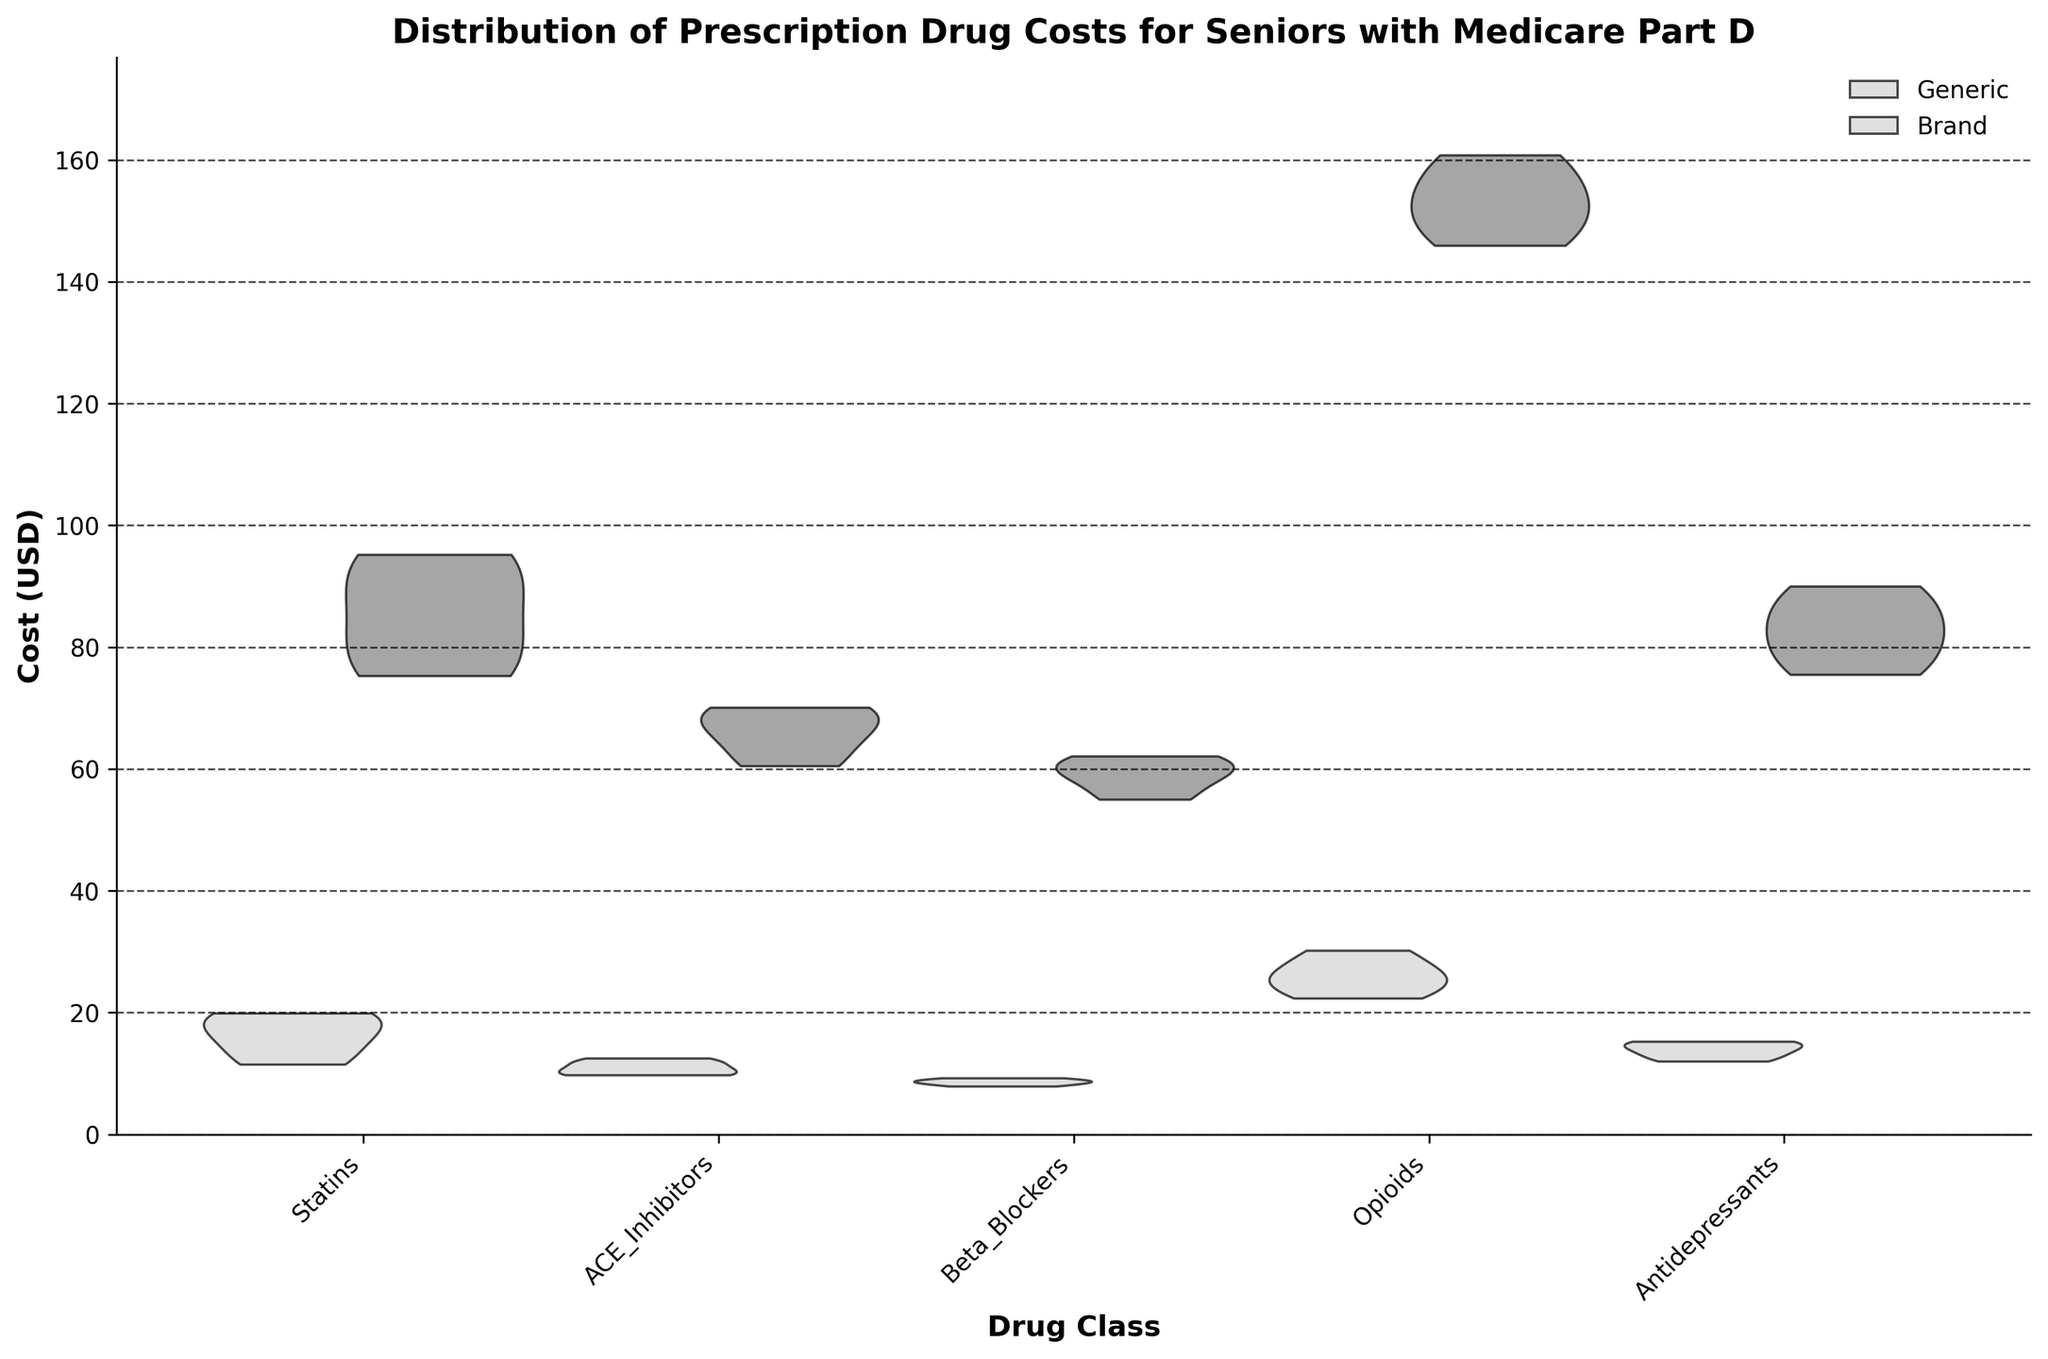How many drug classes are compared in the figure? Count the unique drug classes labeled on the x-axis. There are Statins, ACE Inhibitors, Beta Blockers, Opioids, and Antidepressants.
Answer: 5 What do the two different shades of the violins represent? Observe the legend in the upper right corner. It indicates that the lighter shade represents Generic drugs and the darker shade represents Brand drugs.
Answer: Generic and Brand drugs Which drug class has the highest cost variation for Brand drugs? Compare the width and spread of the darker violin plots for each drug class. The Brand Opioids display the widest and most varied distribution.
Answer: Opioids Is the median cost of Generic Opioids higher than that of Generic Beta Blockers? The median value lies roughly in the middle of the distribution in the violin plots. The Generic Opioids have a higher midpoint (around $25) compared to Generic Beta Blockers (around $8-$9).
Answer: Yes Are the costs for Generic drugs generally more tightly clustered than Brand drugs? Examine the spread of the lighter versus darker violin plots. The lighter violin plots (Generic) are generally narrower, indicating less variation.
Answer: Yes Which age group has the lowest cost for Generic Statins? The violin plot does not break down data by age group directly. However, analyzing the data shows the 75-79 age group has the lowest mean at $11.50.
Answer: 75-79 Which drug class shows the smallest cost difference between Generic and Brand drugs? Compare the distances between the peaks of the lighter and darker violins for each drug class. Beta Blockers show the smallest difference.
Answer: Beta Blockers Do Brand Antidepressants or Brand Statins have a higher average cost? Observe the height and central tendency of the dark violin plots. Brand Antidepressants peak around $75-$90, while Brand Statins peak around $75-$95. Statins have a slightly higher average cost.
Answer: Brand Statins What's the average cost for Generic ACE Inhibitors? Adding the costs for each age group (10.00 + 12.50 + 9.75 + 11.50) and dividing by 4 gives the average: (43.75 / 4) = $10.94.
Answer: $10.94 